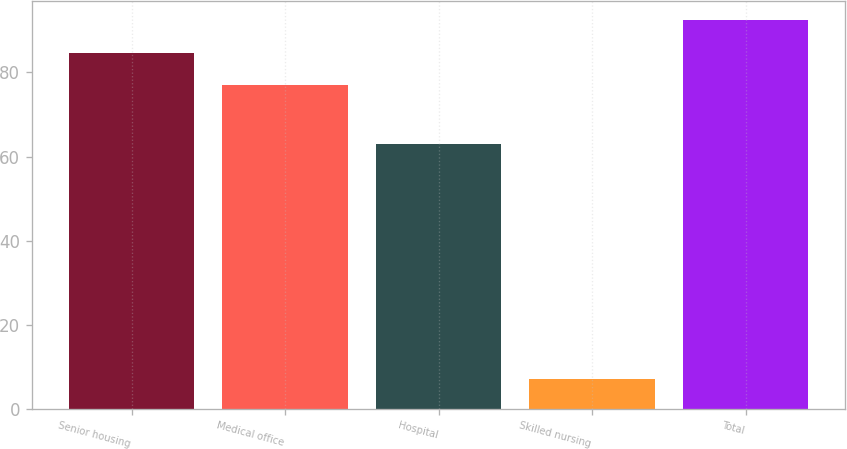<chart> <loc_0><loc_0><loc_500><loc_500><bar_chart><fcel>Senior housing<fcel>Medical office<fcel>Hospital<fcel>Skilled nursing<fcel>Total<nl><fcel>84.7<fcel>77<fcel>63<fcel>7<fcel>92.4<nl></chart> 